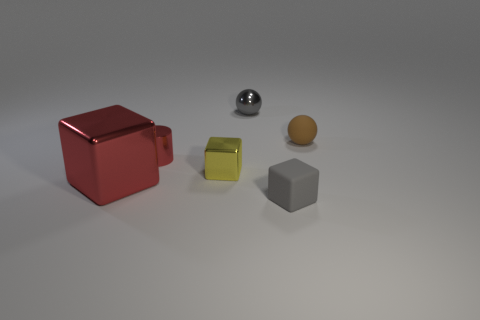Subtract 1 blocks. How many blocks are left? 2 Subtract all large cubes. How many cubes are left? 2 Add 3 tiny blue matte cylinders. How many objects exist? 9 Subtract all spheres. How many objects are left? 4 Add 6 small brown rubber objects. How many small brown rubber objects are left? 7 Add 3 tiny metal cubes. How many tiny metal cubes exist? 4 Subtract 0 blue cylinders. How many objects are left? 6 Subtract all green cubes. Subtract all brown cylinders. How many cubes are left? 3 Subtract all tiny yellow objects. Subtract all red metal cubes. How many objects are left? 4 